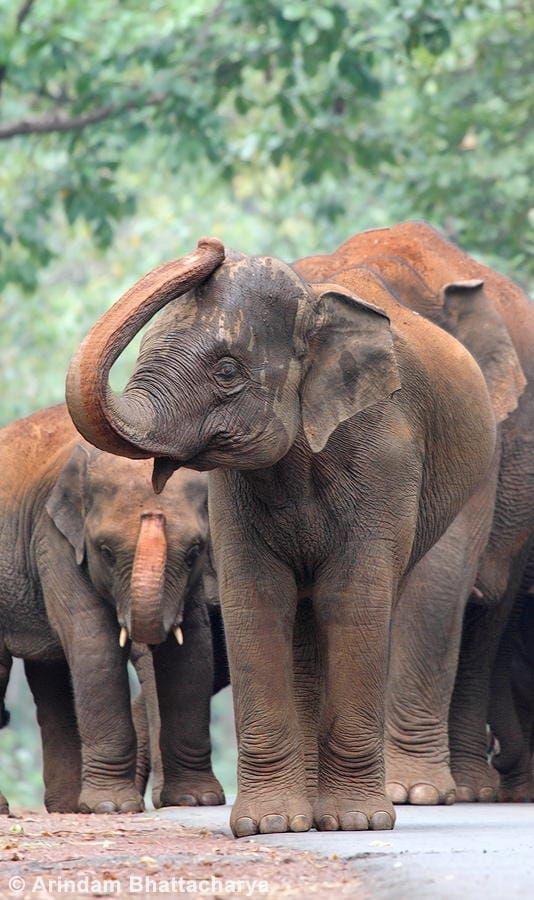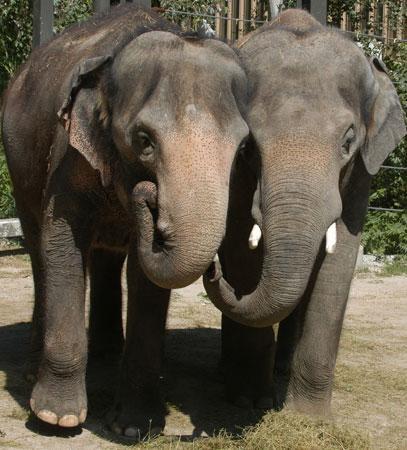The first image is the image on the left, the second image is the image on the right. Assess this claim about the two images: "An image shows two elephants face-to-face with their faces touching.". Correct or not? Answer yes or no. No. The first image is the image on the left, the second image is the image on the right. Assess this claim about the two images: "Two elephants are butting heads in one of the images.". Correct or not? Answer yes or no. No. 